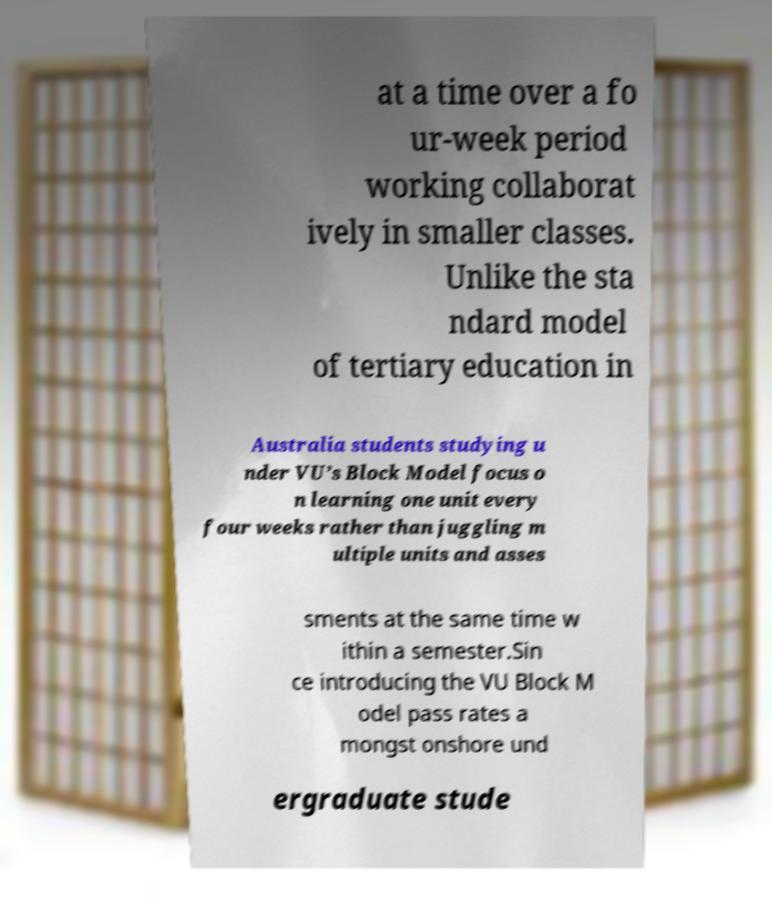Could you assist in decoding the text presented in this image and type it out clearly? at a time over a fo ur-week period working collaborat ively in smaller classes. Unlike the sta ndard model of tertiary education in Australia students studying u nder VU’s Block Model focus o n learning one unit every four weeks rather than juggling m ultiple units and asses sments at the same time w ithin a semester.Sin ce introducing the VU Block M odel pass rates a mongst onshore und ergraduate stude 